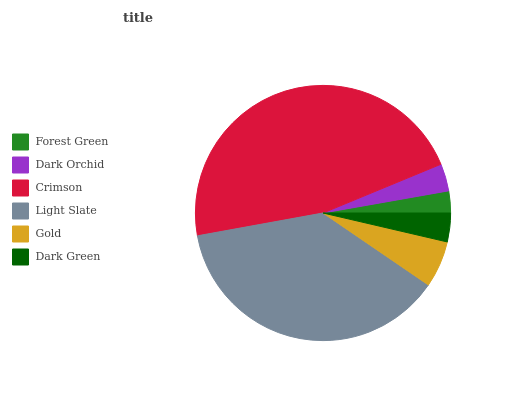Is Forest Green the minimum?
Answer yes or no. Yes. Is Crimson the maximum?
Answer yes or no. Yes. Is Dark Orchid the minimum?
Answer yes or no. No. Is Dark Orchid the maximum?
Answer yes or no. No. Is Dark Orchid greater than Forest Green?
Answer yes or no. Yes. Is Forest Green less than Dark Orchid?
Answer yes or no. Yes. Is Forest Green greater than Dark Orchid?
Answer yes or no. No. Is Dark Orchid less than Forest Green?
Answer yes or no. No. Is Gold the high median?
Answer yes or no. Yes. Is Dark Green the low median?
Answer yes or no. Yes. Is Dark Orchid the high median?
Answer yes or no. No. Is Light Slate the low median?
Answer yes or no. No. 